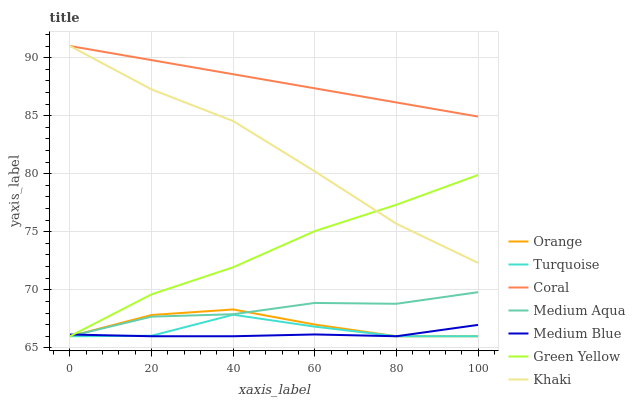Does Medium Blue have the minimum area under the curve?
Answer yes or no. Yes. Does Coral have the maximum area under the curve?
Answer yes or no. Yes. Does Khaki have the minimum area under the curve?
Answer yes or no. No. Does Khaki have the maximum area under the curve?
Answer yes or no. No. Is Coral the smoothest?
Answer yes or no. Yes. Is Turquoise the roughest?
Answer yes or no. Yes. Is Khaki the smoothest?
Answer yes or no. No. Is Khaki the roughest?
Answer yes or no. No. Does Turquoise have the lowest value?
Answer yes or no. Yes. Does Khaki have the lowest value?
Answer yes or no. No. Does Coral have the highest value?
Answer yes or no. Yes. Does Medium Blue have the highest value?
Answer yes or no. No. Is Medium Blue less than Khaki?
Answer yes or no. Yes. Is Khaki greater than Orange?
Answer yes or no. Yes. Does Medium Blue intersect Green Yellow?
Answer yes or no. Yes. Is Medium Blue less than Green Yellow?
Answer yes or no. No. Is Medium Blue greater than Green Yellow?
Answer yes or no. No. Does Medium Blue intersect Khaki?
Answer yes or no. No. 